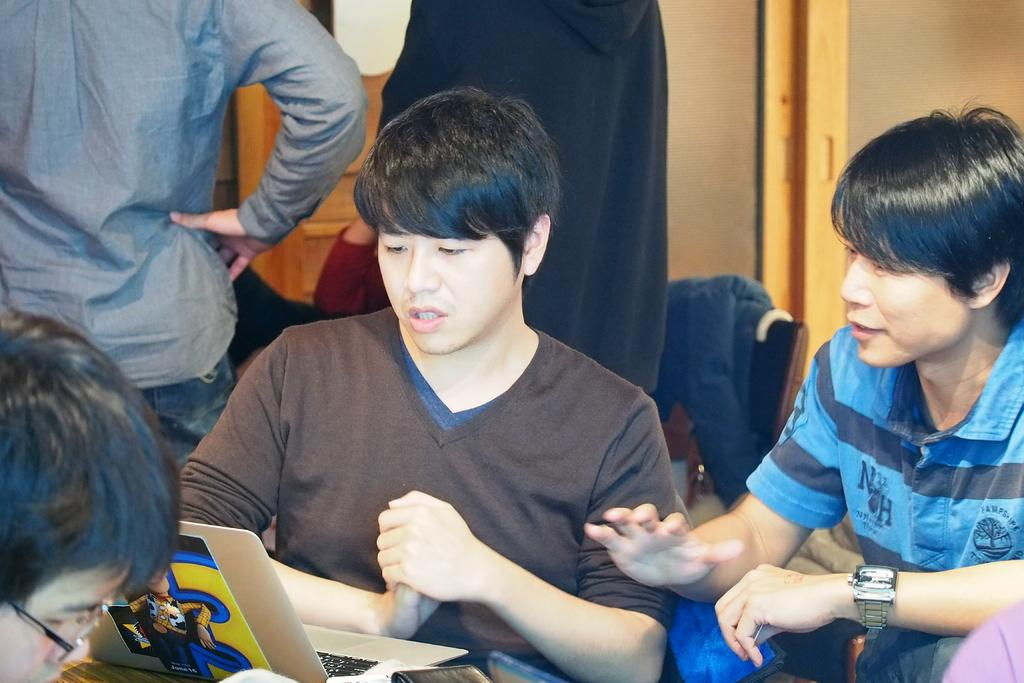What are the persons in the image wearing? The persons in the image are wearing clothes. What type of electronic device is visible at the bottom of the image? There is a laptop at the bottom of the image. What type of bag is being carried by the fearful man in the image? There is no man, fear, or bag present in the image. 